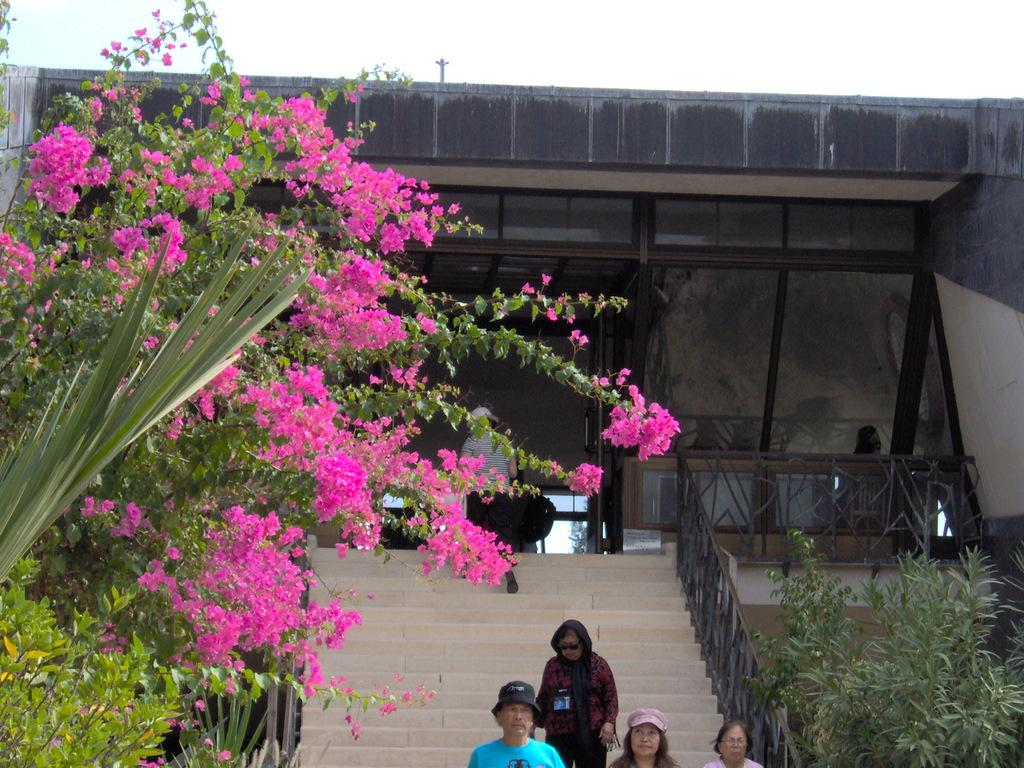What type of vegetation can be seen in the image? There are trees, flowers, and plants in the image. What architectural feature is present in the image? There are stairs in the image. Are there any human subjects in the image? Yes, there are people in the image. What type of structure is visible in the image? There is a building in the image. What is visible at the top of the image? The sky is visible at the top of the image. What type of relation do the people in the image have with each other? There is no information provided about the relationships between the people in the image, so it cannot be determined. Can you tell me how many times the people in the image talk to each other? There is no information provided about any conversations or interactions between the people in the image, so it cannot be determined. 